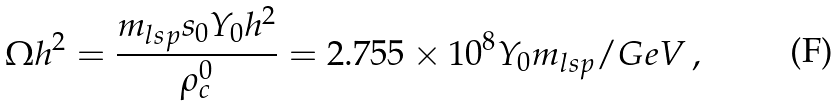<formula> <loc_0><loc_0><loc_500><loc_500>\Omega h ^ { 2 } = \frac { m _ { l s p } s _ { 0 } Y _ { 0 } h ^ { 2 } } { \rho _ { c } ^ { 0 } } = 2 . 7 5 5 \times 1 0 ^ { 8 } Y _ { 0 } m _ { l s p } / G e V \, ,</formula> 